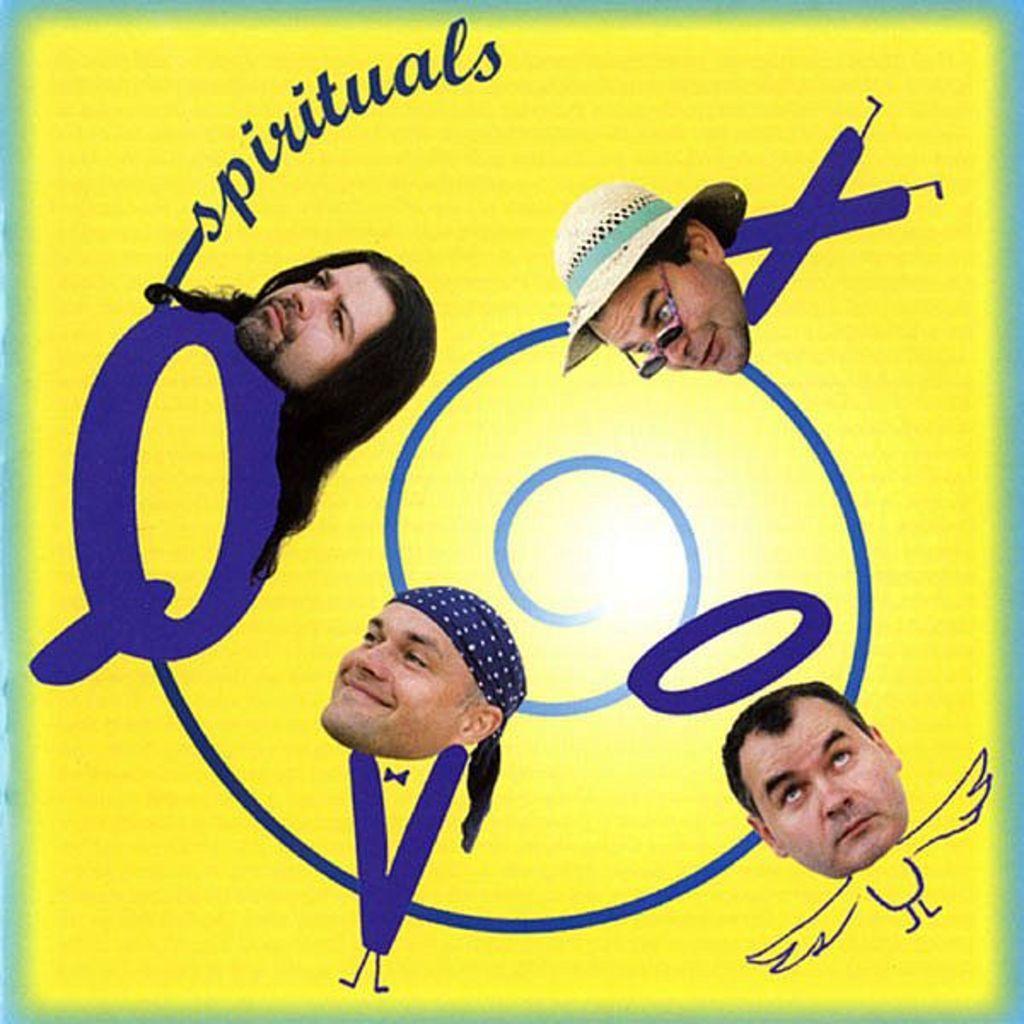Please provide a concise description of this image. This is an edited image. Here I can see four persons heads along with some blue color text. The background is in yellow color. 